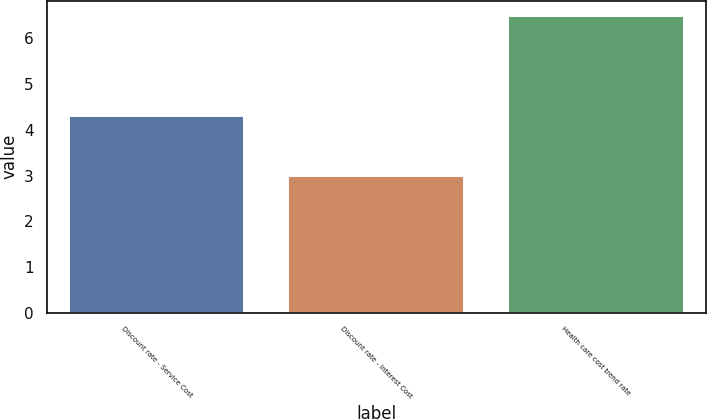Convert chart to OTSL. <chart><loc_0><loc_0><loc_500><loc_500><bar_chart><fcel>Discount rate - Service Cost<fcel>Discount rate - Interest Cost<fcel>Health care cost trend rate<nl><fcel>4.3<fcel>3<fcel>6.5<nl></chart> 